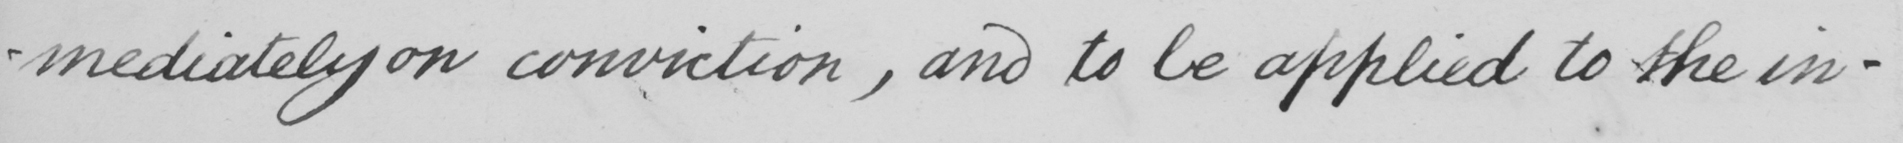Please provide the text content of this handwritten line. -mediately on conviction , and to be applied to the in- 